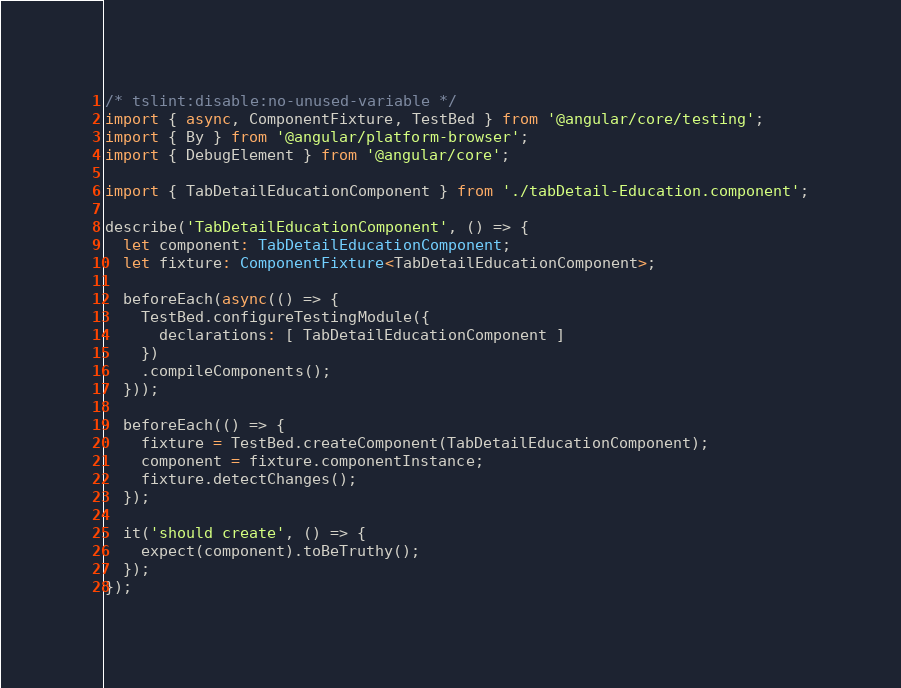Convert code to text. <code><loc_0><loc_0><loc_500><loc_500><_TypeScript_>/* tslint:disable:no-unused-variable */
import { async, ComponentFixture, TestBed } from '@angular/core/testing';
import { By } from '@angular/platform-browser';
import { DebugElement } from '@angular/core';

import { TabDetailEducationComponent } from './tabDetail-Education.component';

describe('TabDetailEducationComponent', () => {
  let component: TabDetailEducationComponent;
  let fixture: ComponentFixture<TabDetailEducationComponent>;

  beforeEach(async(() => {
    TestBed.configureTestingModule({
      declarations: [ TabDetailEducationComponent ]
    })
    .compileComponents();
  }));

  beforeEach(() => {
    fixture = TestBed.createComponent(TabDetailEducationComponent);
    component = fixture.componentInstance;
    fixture.detectChanges();
  });

  it('should create', () => {
    expect(component).toBeTruthy();
  });
});
</code> 